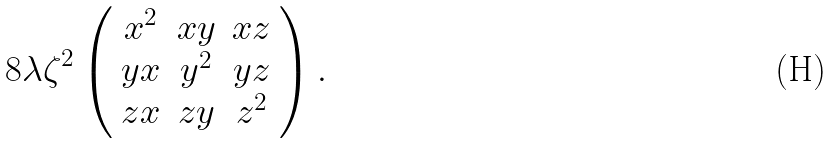<formula> <loc_0><loc_0><loc_500><loc_500>8 \lambda \zeta ^ { 2 } \left ( \begin{array} { c c c } { { x ^ { 2 } } } & { x y } & { x z } \\ { y x } & { { y ^ { 2 } } } & { y z } \\ { z x } & { z y } & { { z ^ { 2 } } } \end{array} \right ) .</formula> 